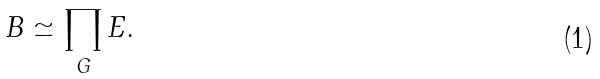<formula> <loc_0><loc_0><loc_500><loc_500>B \simeq \prod _ { G } E .</formula> 